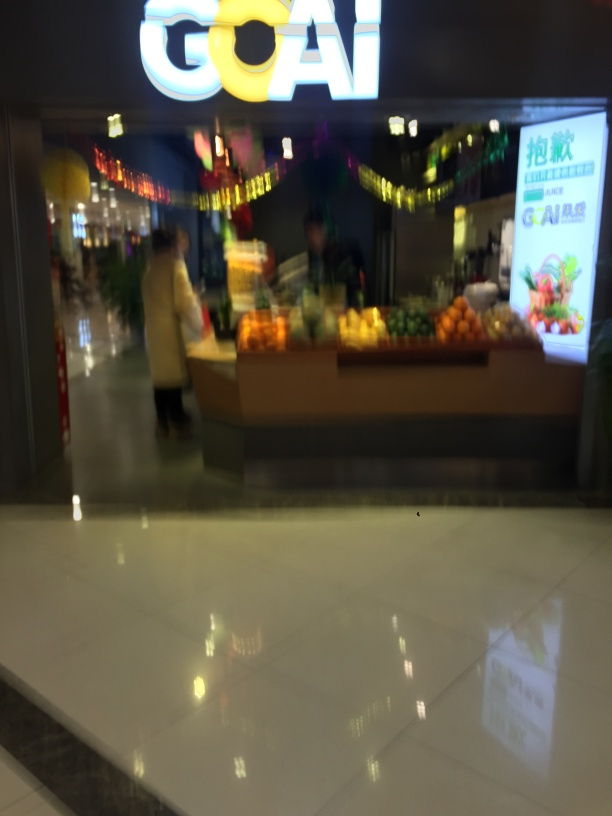What kind of establishment is pictured in the image? The image shows an indoor setting with a fruit stall that has an array of colorful fruits on display, indicating that this is likely a market or grocery section within a larger complex. 